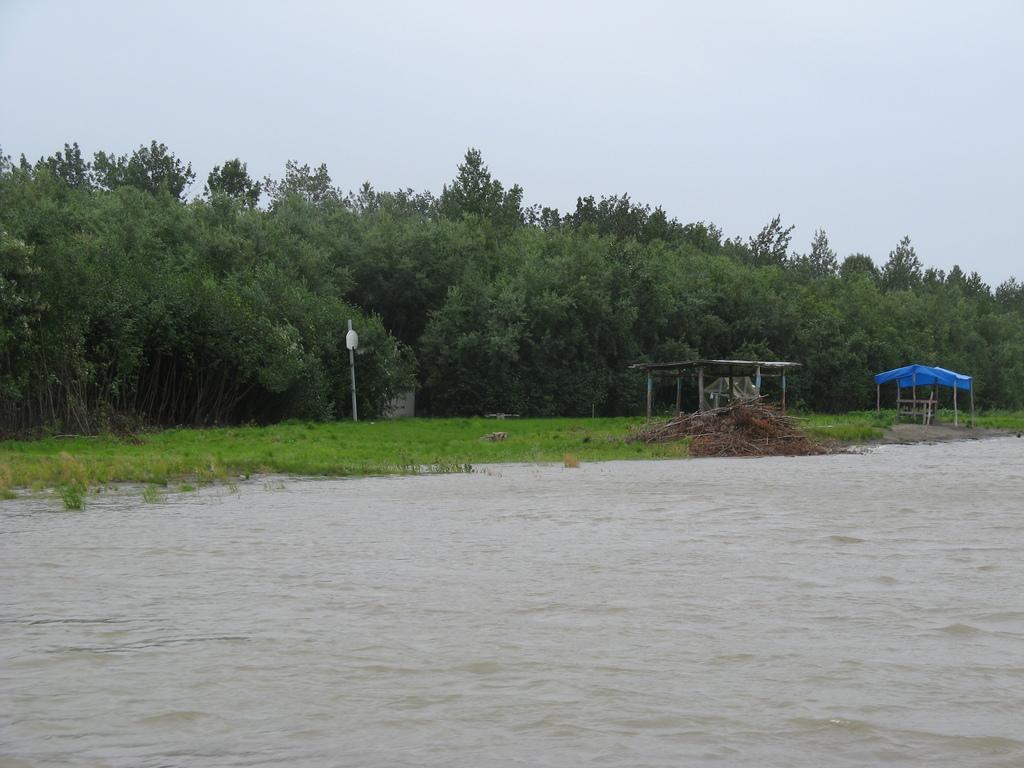Please provide a concise description of this image. This is the water flowing. I can see a bunch of branches. These are the shelters. I think this is the pole. These are the trees with branches and leaves. Here is the grass. 